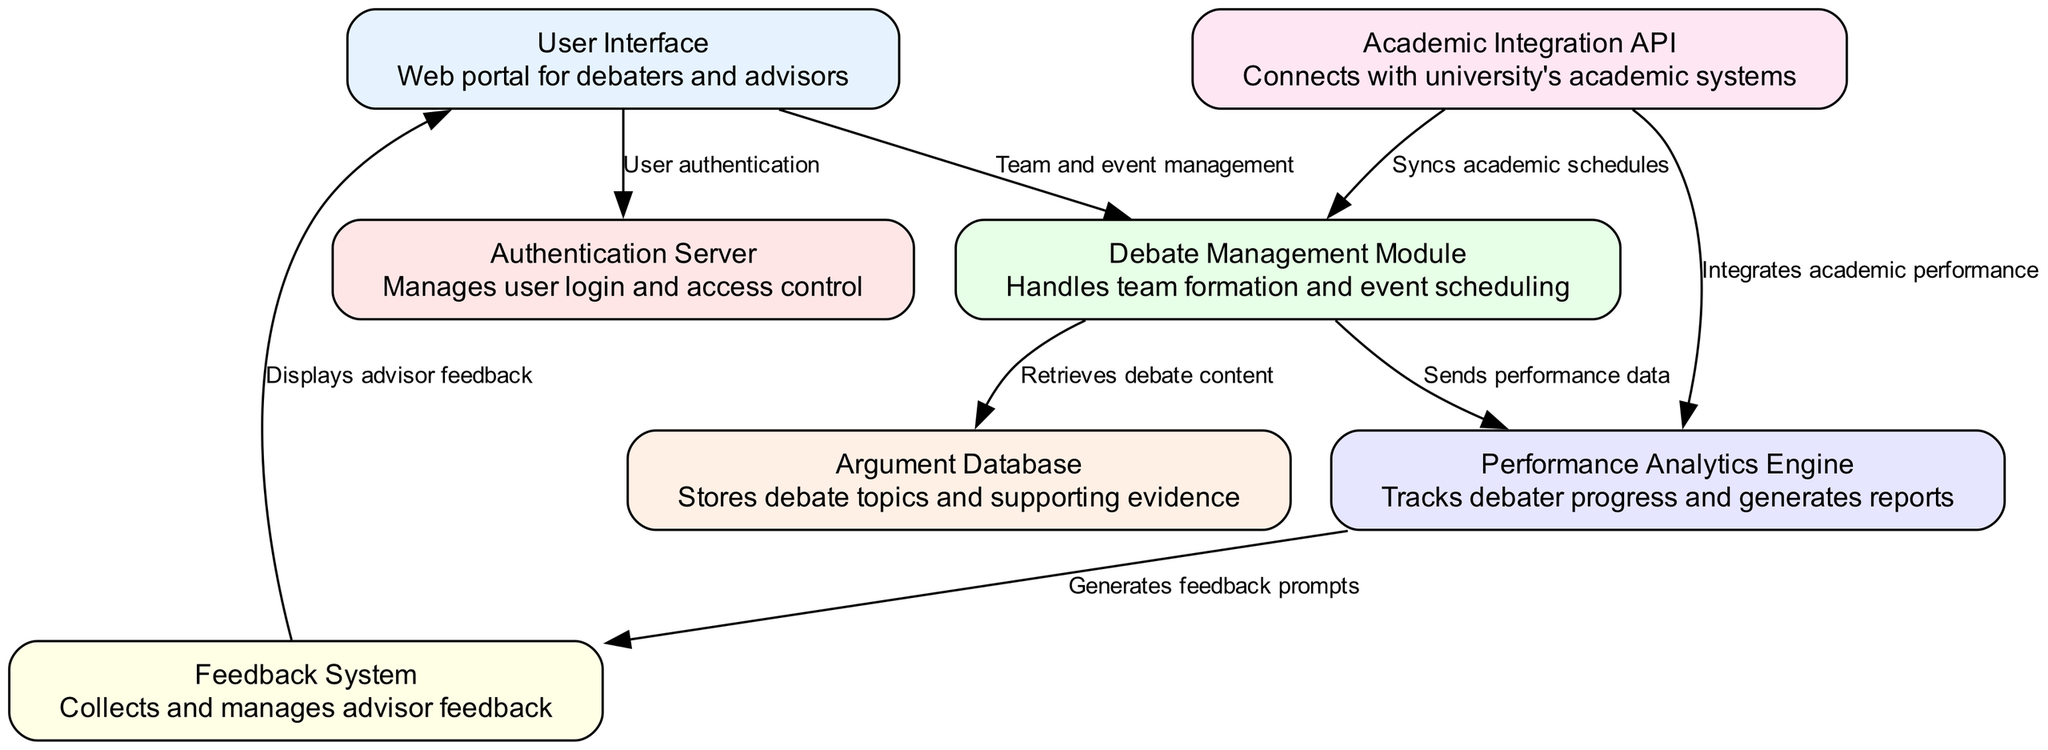What is the total number of nodes in the diagram? The diagram lists a total of seven nodes. To find this, we count each unique node identified in the "nodes" section of the data.
Answer: 7 Which node manages user login and access control? The "Authentication Server" node is responsible for managing user login and access control, as described in its description within the diagram.
Answer: Authentication Server What is the function of the "Debate Management Module"? The function of the "Debate Management Module" is to handle team formation and event scheduling, as stated in its description in the diagram.
Answer: Handles team formation and event scheduling How does the "Performance Analytics Engine" interact with the "Feedback System"? The "Performance Analytics Engine" generates feedback prompts that are sent to the "Feedback System," which then interacts with the user interface to display this feedback. To answer this, we need to trace the edge connecting nodes 5 and 6 labeled "Generates feedback prompts."
Answer: Generates feedback prompts What color is associated with the "Argument Database" node? The "Argument Database" node corresponds to the third color in the specified color palette used for nodes in the diagram. Each color is assigned to a node based on the order they appear. The third node receives the color associated with the color index for number three, which is #E6FFE6.
Answer: #E6FFE6 Which two modules connect to the "Academic Integration API"? The "Debate Management Module" and "Performance Analytics Engine" both connect to the "Academic Integration API." This can be reasoned through the edges starting from node 7 that lead to nodes 3 and 5 respectively.
Answer: Debate Management Module, Performance Analytics Engine What action does the "User Interface" take towards the "Authentication Server"? The "User Interface" uses the authentication process by connecting to the "Authentication Server" for user authentication, as denoted by the edge labeled "User authentication."
Answer: User authentication Which node displays advisor feedback? The "User Interface" node displays advisor feedback, as indicated by the edge connecting the "Feedback System" to the "User Interface," labeled "Displays advisor feedback."
Answer: User Interface What relationship exists between the "Debate Management Module" and the "Argument Database"? The relationship is that the "Debate Management Module" retrieves debate content from the "Argument Database," as established by the direct edge labeled "Retrieves debate content."
Answer: Retrieves debate content 